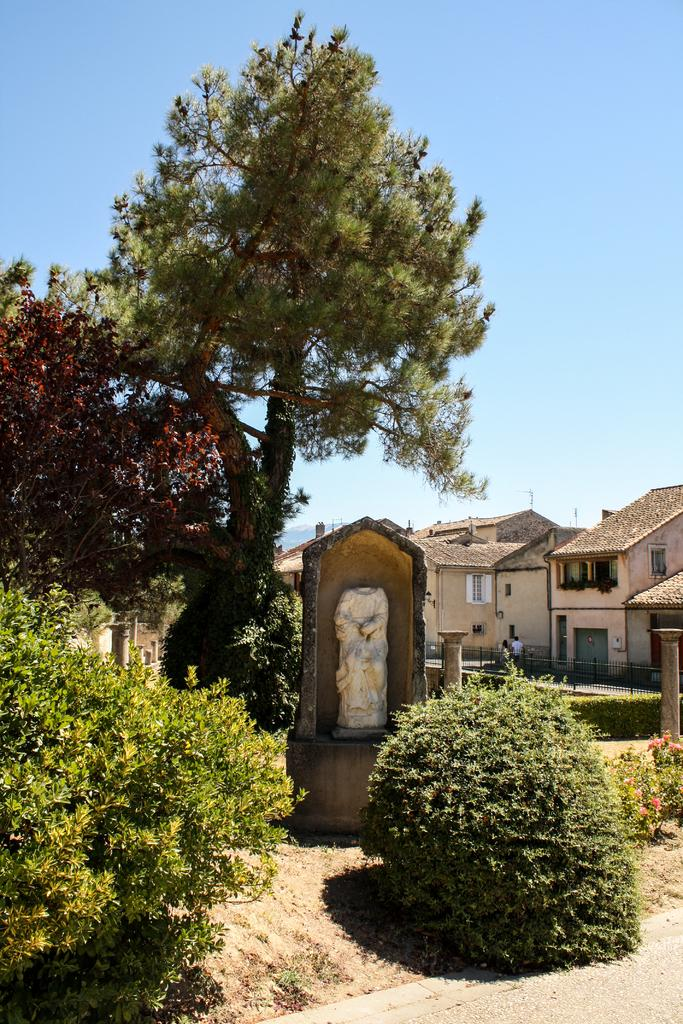What type of natural elements can be seen in the image? There are trees and plants visible in the image. What is located on a platform in the image? There is a statue on a platform in the image. What can be seen in the background of the image? There are houses, persons, windows, roofs, and the sky visible in the background of the image. What type of pipe is being played by the committee in the image? There is no committee or pipe present in the image; it features trees, plants, a statue, and various background elements. How many sails can be seen on the boats in the image? There are no boats or sails present in the image. 